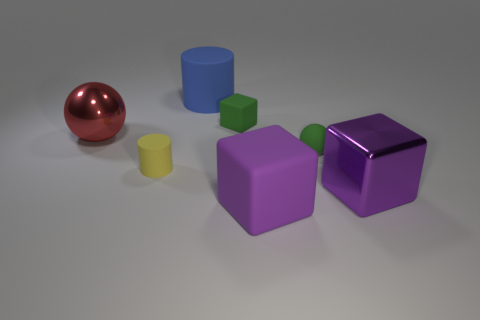Subtract all purple spheres. How many purple cubes are left? 2 Subtract all large purple rubber blocks. How many blocks are left? 2 Add 1 blue objects. How many objects exist? 8 Subtract all balls. How many objects are left? 5 Add 2 big cubes. How many big cubes are left? 4 Add 2 large purple rubber objects. How many large purple rubber objects exist? 3 Subtract 1 yellow cylinders. How many objects are left? 6 Subtract all blue cylinders. Subtract all big red balls. How many objects are left? 5 